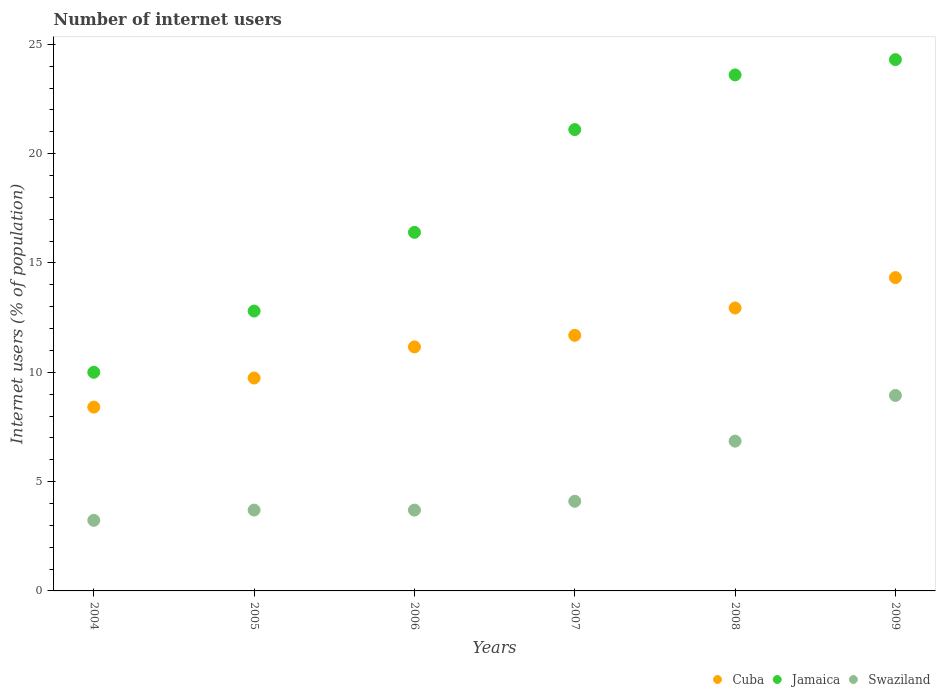What is the number of internet users in Cuba in 2009?
Offer a terse response. 14.33. Across all years, what is the maximum number of internet users in Jamaica?
Make the answer very short. 24.3. Across all years, what is the minimum number of internet users in Cuba?
Keep it short and to the point. 8.41. In which year was the number of internet users in Jamaica minimum?
Give a very brief answer. 2004. What is the total number of internet users in Jamaica in the graph?
Provide a short and direct response. 108.2. What is the difference between the number of internet users in Cuba in 2007 and that in 2008?
Your answer should be compact. -1.25. What is the difference between the number of internet users in Jamaica in 2006 and the number of internet users in Swaziland in 2008?
Ensure brevity in your answer.  9.55. What is the average number of internet users in Jamaica per year?
Your answer should be compact. 18.03. In the year 2009, what is the difference between the number of internet users in Swaziland and number of internet users in Cuba?
Ensure brevity in your answer.  -5.39. In how many years, is the number of internet users in Jamaica greater than 21 %?
Give a very brief answer. 3. What is the ratio of the number of internet users in Jamaica in 2006 to that in 2008?
Offer a terse response. 0.69. Is the number of internet users in Cuba in 2004 less than that in 2008?
Ensure brevity in your answer.  Yes. Is the difference between the number of internet users in Swaziland in 2007 and 2009 greater than the difference between the number of internet users in Cuba in 2007 and 2009?
Your answer should be very brief. No. What is the difference between the highest and the second highest number of internet users in Cuba?
Provide a succinct answer. 1.39. What is the difference between the highest and the lowest number of internet users in Swaziland?
Provide a short and direct response. 5.71. In how many years, is the number of internet users in Jamaica greater than the average number of internet users in Jamaica taken over all years?
Offer a very short reply. 3. Is the sum of the number of internet users in Swaziland in 2007 and 2009 greater than the maximum number of internet users in Jamaica across all years?
Ensure brevity in your answer.  No. Is it the case that in every year, the sum of the number of internet users in Swaziland and number of internet users in Jamaica  is greater than the number of internet users in Cuba?
Provide a succinct answer. Yes. How many years are there in the graph?
Provide a succinct answer. 6. What is the difference between two consecutive major ticks on the Y-axis?
Provide a succinct answer. 5. Are the values on the major ticks of Y-axis written in scientific E-notation?
Provide a succinct answer. No. Does the graph contain any zero values?
Keep it short and to the point. No. Does the graph contain grids?
Offer a terse response. No. How are the legend labels stacked?
Give a very brief answer. Horizontal. What is the title of the graph?
Offer a terse response. Number of internet users. What is the label or title of the Y-axis?
Offer a terse response. Internet users (% of population). What is the Internet users (% of population) in Cuba in 2004?
Your answer should be compact. 8.41. What is the Internet users (% of population) of Jamaica in 2004?
Your answer should be very brief. 10. What is the Internet users (% of population) in Swaziland in 2004?
Give a very brief answer. 3.23. What is the Internet users (% of population) of Cuba in 2005?
Provide a succinct answer. 9.74. What is the Internet users (% of population) of Swaziland in 2005?
Give a very brief answer. 3.7. What is the Internet users (% of population) of Cuba in 2006?
Provide a short and direct response. 11.16. What is the Internet users (% of population) of Swaziland in 2006?
Keep it short and to the point. 3.7. What is the Internet users (% of population) in Cuba in 2007?
Ensure brevity in your answer.  11.69. What is the Internet users (% of population) in Jamaica in 2007?
Your answer should be very brief. 21.1. What is the Internet users (% of population) in Swaziland in 2007?
Your answer should be compact. 4.1. What is the Internet users (% of population) of Cuba in 2008?
Provide a short and direct response. 12.94. What is the Internet users (% of population) in Jamaica in 2008?
Ensure brevity in your answer.  23.6. What is the Internet users (% of population) in Swaziland in 2008?
Ensure brevity in your answer.  6.85. What is the Internet users (% of population) in Cuba in 2009?
Make the answer very short. 14.33. What is the Internet users (% of population) in Jamaica in 2009?
Make the answer very short. 24.3. What is the Internet users (% of population) of Swaziland in 2009?
Provide a succinct answer. 8.94. Across all years, what is the maximum Internet users (% of population) of Cuba?
Your response must be concise. 14.33. Across all years, what is the maximum Internet users (% of population) of Jamaica?
Provide a short and direct response. 24.3. Across all years, what is the maximum Internet users (% of population) in Swaziland?
Your answer should be compact. 8.94. Across all years, what is the minimum Internet users (% of population) in Cuba?
Your answer should be very brief. 8.41. Across all years, what is the minimum Internet users (% of population) of Swaziland?
Offer a terse response. 3.23. What is the total Internet users (% of population) of Cuba in the graph?
Offer a very short reply. 68.27. What is the total Internet users (% of population) in Jamaica in the graph?
Offer a terse response. 108.2. What is the total Internet users (% of population) of Swaziland in the graph?
Your answer should be very brief. 30.51. What is the difference between the Internet users (% of population) of Cuba in 2004 and that in 2005?
Your answer should be very brief. -1.33. What is the difference between the Internet users (% of population) in Jamaica in 2004 and that in 2005?
Provide a succinct answer. -2.8. What is the difference between the Internet users (% of population) in Swaziland in 2004 and that in 2005?
Keep it short and to the point. -0.47. What is the difference between the Internet users (% of population) in Cuba in 2004 and that in 2006?
Offer a very short reply. -2.75. What is the difference between the Internet users (% of population) of Jamaica in 2004 and that in 2006?
Offer a very short reply. -6.4. What is the difference between the Internet users (% of population) of Swaziland in 2004 and that in 2006?
Your response must be concise. -0.47. What is the difference between the Internet users (% of population) in Cuba in 2004 and that in 2007?
Offer a terse response. -3.28. What is the difference between the Internet users (% of population) of Jamaica in 2004 and that in 2007?
Provide a short and direct response. -11.1. What is the difference between the Internet users (% of population) of Swaziland in 2004 and that in 2007?
Provide a succinct answer. -0.87. What is the difference between the Internet users (% of population) in Cuba in 2004 and that in 2008?
Offer a terse response. -4.53. What is the difference between the Internet users (% of population) in Jamaica in 2004 and that in 2008?
Provide a succinct answer. -13.6. What is the difference between the Internet users (% of population) in Swaziland in 2004 and that in 2008?
Offer a very short reply. -3.62. What is the difference between the Internet users (% of population) in Cuba in 2004 and that in 2009?
Offer a terse response. -5.92. What is the difference between the Internet users (% of population) in Jamaica in 2004 and that in 2009?
Keep it short and to the point. -14.3. What is the difference between the Internet users (% of population) in Swaziland in 2004 and that in 2009?
Ensure brevity in your answer.  -5.71. What is the difference between the Internet users (% of population) of Cuba in 2005 and that in 2006?
Offer a very short reply. -1.42. What is the difference between the Internet users (% of population) in Jamaica in 2005 and that in 2006?
Offer a very short reply. -3.6. What is the difference between the Internet users (% of population) in Cuba in 2005 and that in 2007?
Keep it short and to the point. -1.95. What is the difference between the Internet users (% of population) in Jamaica in 2005 and that in 2007?
Ensure brevity in your answer.  -8.3. What is the difference between the Internet users (% of population) in Swaziland in 2005 and that in 2007?
Offer a very short reply. -0.4. What is the difference between the Internet users (% of population) in Cuba in 2005 and that in 2008?
Offer a terse response. -3.2. What is the difference between the Internet users (% of population) in Jamaica in 2005 and that in 2008?
Your response must be concise. -10.8. What is the difference between the Internet users (% of population) of Swaziland in 2005 and that in 2008?
Provide a short and direct response. -3.15. What is the difference between the Internet users (% of population) of Cuba in 2005 and that in 2009?
Your answer should be very brief. -4.59. What is the difference between the Internet users (% of population) of Swaziland in 2005 and that in 2009?
Make the answer very short. -5.24. What is the difference between the Internet users (% of population) in Cuba in 2006 and that in 2007?
Provide a succinct answer. -0.53. What is the difference between the Internet users (% of population) of Jamaica in 2006 and that in 2007?
Provide a short and direct response. -4.7. What is the difference between the Internet users (% of population) of Swaziland in 2006 and that in 2007?
Provide a succinct answer. -0.4. What is the difference between the Internet users (% of population) in Cuba in 2006 and that in 2008?
Provide a succinct answer. -1.78. What is the difference between the Internet users (% of population) in Swaziland in 2006 and that in 2008?
Provide a succinct answer. -3.15. What is the difference between the Internet users (% of population) in Cuba in 2006 and that in 2009?
Your answer should be very brief. -3.17. What is the difference between the Internet users (% of population) in Jamaica in 2006 and that in 2009?
Offer a very short reply. -7.9. What is the difference between the Internet users (% of population) of Swaziland in 2006 and that in 2009?
Ensure brevity in your answer.  -5.24. What is the difference between the Internet users (% of population) of Cuba in 2007 and that in 2008?
Your answer should be very brief. -1.25. What is the difference between the Internet users (% of population) of Jamaica in 2007 and that in 2008?
Provide a succinct answer. -2.5. What is the difference between the Internet users (% of population) in Swaziland in 2007 and that in 2008?
Offer a terse response. -2.75. What is the difference between the Internet users (% of population) in Cuba in 2007 and that in 2009?
Your answer should be compact. -2.64. What is the difference between the Internet users (% of population) of Swaziland in 2007 and that in 2009?
Your answer should be very brief. -4.84. What is the difference between the Internet users (% of population) of Cuba in 2008 and that in 2009?
Give a very brief answer. -1.39. What is the difference between the Internet users (% of population) of Jamaica in 2008 and that in 2009?
Offer a very short reply. -0.7. What is the difference between the Internet users (% of population) in Swaziland in 2008 and that in 2009?
Your answer should be compact. -2.09. What is the difference between the Internet users (% of population) in Cuba in 2004 and the Internet users (% of population) in Jamaica in 2005?
Your answer should be very brief. -4.39. What is the difference between the Internet users (% of population) of Cuba in 2004 and the Internet users (% of population) of Swaziland in 2005?
Offer a terse response. 4.71. What is the difference between the Internet users (% of population) in Jamaica in 2004 and the Internet users (% of population) in Swaziland in 2005?
Ensure brevity in your answer.  6.3. What is the difference between the Internet users (% of population) in Cuba in 2004 and the Internet users (% of population) in Jamaica in 2006?
Give a very brief answer. -7.99. What is the difference between the Internet users (% of population) in Cuba in 2004 and the Internet users (% of population) in Swaziland in 2006?
Keep it short and to the point. 4.71. What is the difference between the Internet users (% of population) of Jamaica in 2004 and the Internet users (% of population) of Swaziland in 2006?
Offer a terse response. 6.3. What is the difference between the Internet users (% of population) in Cuba in 2004 and the Internet users (% of population) in Jamaica in 2007?
Your response must be concise. -12.69. What is the difference between the Internet users (% of population) of Cuba in 2004 and the Internet users (% of population) of Swaziland in 2007?
Make the answer very short. 4.31. What is the difference between the Internet users (% of population) of Cuba in 2004 and the Internet users (% of population) of Jamaica in 2008?
Make the answer very short. -15.19. What is the difference between the Internet users (% of population) in Cuba in 2004 and the Internet users (% of population) in Swaziland in 2008?
Provide a short and direct response. 1.56. What is the difference between the Internet users (% of population) of Jamaica in 2004 and the Internet users (% of population) of Swaziland in 2008?
Your answer should be compact. 3.15. What is the difference between the Internet users (% of population) in Cuba in 2004 and the Internet users (% of population) in Jamaica in 2009?
Keep it short and to the point. -15.89. What is the difference between the Internet users (% of population) of Cuba in 2004 and the Internet users (% of population) of Swaziland in 2009?
Your answer should be very brief. -0.53. What is the difference between the Internet users (% of population) of Jamaica in 2004 and the Internet users (% of population) of Swaziland in 2009?
Your answer should be compact. 1.06. What is the difference between the Internet users (% of population) in Cuba in 2005 and the Internet users (% of population) in Jamaica in 2006?
Provide a succinct answer. -6.66. What is the difference between the Internet users (% of population) of Cuba in 2005 and the Internet users (% of population) of Swaziland in 2006?
Your answer should be very brief. 6.04. What is the difference between the Internet users (% of population) in Jamaica in 2005 and the Internet users (% of population) in Swaziland in 2006?
Provide a short and direct response. 9.1. What is the difference between the Internet users (% of population) of Cuba in 2005 and the Internet users (% of population) of Jamaica in 2007?
Make the answer very short. -11.36. What is the difference between the Internet users (% of population) of Cuba in 2005 and the Internet users (% of population) of Swaziland in 2007?
Provide a succinct answer. 5.64. What is the difference between the Internet users (% of population) of Cuba in 2005 and the Internet users (% of population) of Jamaica in 2008?
Keep it short and to the point. -13.86. What is the difference between the Internet users (% of population) of Cuba in 2005 and the Internet users (% of population) of Swaziland in 2008?
Your response must be concise. 2.89. What is the difference between the Internet users (% of population) of Jamaica in 2005 and the Internet users (% of population) of Swaziland in 2008?
Ensure brevity in your answer.  5.95. What is the difference between the Internet users (% of population) of Cuba in 2005 and the Internet users (% of population) of Jamaica in 2009?
Give a very brief answer. -14.56. What is the difference between the Internet users (% of population) in Cuba in 2005 and the Internet users (% of population) in Swaziland in 2009?
Offer a very short reply. 0.8. What is the difference between the Internet users (% of population) of Jamaica in 2005 and the Internet users (% of population) of Swaziland in 2009?
Ensure brevity in your answer.  3.86. What is the difference between the Internet users (% of population) of Cuba in 2006 and the Internet users (% of population) of Jamaica in 2007?
Ensure brevity in your answer.  -9.94. What is the difference between the Internet users (% of population) in Cuba in 2006 and the Internet users (% of population) in Swaziland in 2007?
Offer a very short reply. 7.06. What is the difference between the Internet users (% of population) of Jamaica in 2006 and the Internet users (% of population) of Swaziland in 2007?
Ensure brevity in your answer.  12.3. What is the difference between the Internet users (% of population) of Cuba in 2006 and the Internet users (% of population) of Jamaica in 2008?
Ensure brevity in your answer.  -12.44. What is the difference between the Internet users (% of population) of Cuba in 2006 and the Internet users (% of population) of Swaziland in 2008?
Provide a succinct answer. 4.31. What is the difference between the Internet users (% of population) of Jamaica in 2006 and the Internet users (% of population) of Swaziland in 2008?
Ensure brevity in your answer.  9.55. What is the difference between the Internet users (% of population) in Cuba in 2006 and the Internet users (% of population) in Jamaica in 2009?
Ensure brevity in your answer.  -13.14. What is the difference between the Internet users (% of population) in Cuba in 2006 and the Internet users (% of population) in Swaziland in 2009?
Offer a terse response. 2.22. What is the difference between the Internet users (% of population) of Jamaica in 2006 and the Internet users (% of population) of Swaziland in 2009?
Ensure brevity in your answer.  7.46. What is the difference between the Internet users (% of population) in Cuba in 2007 and the Internet users (% of population) in Jamaica in 2008?
Ensure brevity in your answer.  -11.91. What is the difference between the Internet users (% of population) in Cuba in 2007 and the Internet users (% of population) in Swaziland in 2008?
Offer a terse response. 4.84. What is the difference between the Internet users (% of population) of Jamaica in 2007 and the Internet users (% of population) of Swaziland in 2008?
Ensure brevity in your answer.  14.25. What is the difference between the Internet users (% of population) in Cuba in 2007 and the Internet users (% of population) in Jamaica in 2009?
Your answer should be compact. -12.61. What is the difference between the Internet users (% of population) in Cuba in 2007 and the Internet users (% of population) in Swaziland in 2009?
Your response must be concise. 2.75. What is the difference between the Internet users (% of population) of Jamaica in 2007 and the Internet users (% of population) of Swaziland in 2009?
Make the answer very short. 12.16. What is the difference between the Internet users (% of population) of Cuba in 2008 and the Internet users (% of population) of Jamaica in 2009?
Provide a short and direct response. -11.36. What is the difference between the Internet users (% of population) in Cuba in 2008 and the Internet users (% of population) in Swaziland in 2009?
Give a very brief answer. 4. What is the difference between the Internet users (% of population) of Jamaica in 2008 and the Internet users (% of population) of Swaziland in 2009?
Ensure brevity in your answer.  14.66. What is the average Internet users (% of population) of Cuba per year?
Provide a succinct answer. 11.38. What is the average Internet users (% of population) in Jamaica per year?
Keep it short and to the point. 18.03. What is the average Internet users (% of population) of Swaziland per year?
Provide a short and direct response. 5.09. In the year 2004, what is the difference between the Internet users (% of population) in Cuba and Internet users (% of population) in Jamaica?
Your answer should be compact. -1.59. In the year 2004, what is the difference between the Internet users (% of population) in Cuba and Internet users (% of population) in Swaziland?
Keep it short and to the point. 5.18. In the year 2004, what is the difference between the Internet users (% of population) in Jamaica and Internet users (% of population) in Swaziland?
Your response must be concise. 6.77. In the year 2005, what is the difference between the Internet users (% of population) in Cuba and Internet users (% of population) in Jamaica?
Ensure brevity in your answer.  -3.06. In the year 2005, what is the difference between the Internet users (% of population) of Cuba and Internet users (% of population) of Swaziland?
Your response must be concise. 6.04. In the year 2005, what is the difference between the Internet users (% of population) in Jamaica and Internet users (% of population) in Swaziland?
Your response must be concise. 9.1. In the year 2006, what is the difference between the Internet users (% of population) of Cuba and Internet users (% of population) of Jamaica?
Your response must be concise. -5.24. In the year 2006, what is the difference between the Internet users (% of population) in Cuba and Internet users (% of population) in Swaziland?
Offer a terse response. 7.46. In the year 2006, what is the difference between the Internet users (% of population) of Jamaica and Internet users (% of population) of Swaziland?
Your response must be concise. 12.7. In the year 2007, what is the difference between the Internet users (% of population) of Cuba and Internet users (% of population) of Jamaica?
Your response must be concise. -9.41. In the year 2007, what is the difference between the Internet users (% of population) of Cuba and Internet users (% of population) of Swaziland?
Give a very brief answer. 7.59. In the year 2008, what is the difference between the Internet users (% of population) of Cuba and Internet users (% of population) of Jamaica?
Give a very brief answer. -10.66. In the year 2008, what is the difference between the Internet users (% of population) of Cuba and Internet users (% of population) of Swaziland?
Ensure brevity in your answer.  6.09. In the year 2008, what is the difference between the Internet users (% of population) of Jamaica and Internet users (% of population) of Swaziland?
Your answer should be very brief. 16.75. In the year 2009, what is the difference between the Internet users (% of population) of Cuba and Internet users (% of population) of Jamaica?
Your response must be concise. -9.97. In the year 2009, what is the difference between the Internet users (% of population) of Cuba and Internet users (% of population) of Swaziland?
Make the answer very short. 5.39. In the year 2009, what is the difference between the Internet users (% of population) in Jamaica and Internet users (% of population) in Swaziland?
Give a very brief answer. 15.36. What is the ratio of the Internet users (% of population) of Cuba in 2004 to that in 2005?
Make the answer very short. 0.86. What is the ratio of the Internet users (% of population) in Jamaica in 2004 to that in 2005?
Keep it short and to the point. 0.78. What is the ratio of the Internet users (% of population) in Swaziland in 2004 to that in 2005?
Provide a succinct answer. 0.87. What is the ratio of the Internet users (% of population) in Cuba in 2004 to that in 2006?
Ensure brevity in your answer.  0.75. What is the ratio of the Internet users (% of population) of Jamaica in 2004 to that in 2006?
Give a very brief answer. 0.61. What is the ratio of the Internet users (% of population) in Swaziland in 2004 to that in 2006?
Your answer should be compact. 0.87. What is the ratio of the Internet users (% of population) in Cuba in 2004 to that in 2007?
Your response must be concise. 0.72. What is the ratio of the Internet users (% of population) in Jamaica in 2004 to that in 2007?
Keep it short and to the point. 0.47. What is the ratio of the Internet users (% of population) in Swaziland in 2004 to that in 2007?
Give a very brief answer. 0.79. What is the ratio of the Internet users (% of population) in Cuba in 2004 to that in 2008?
Ensure brevity in your answer.  0.65. What is the ratio of the Internet users (% of population) in Jamaica in 2004 to that in 2008?
Provide a short and direct response. 0.42. What is the ratio of the Internet users (% of population) in Swaziland in 2004 to that in 2008?
Give a very brief answer. 0.47. What is the ratio of the Internet users (% of population) of Cuba in 2004 to that in 2009?
Your response must be concise. 0.59. What is the ratio of the Internet users (% of population) of Jamaica in 2004 to that in 2009?
Offer a terse response. 0.41. What is the ratio of the Internet users (% of population) in Swaziland in 2004 to that in 2009?
Your response must be concise. 0.36. What is the ratio of the Internet users (% of population) of Cuba in 2005 to that in 2006?
Make the answer very short. 0.87. What is the ratio of the Internet users (% of population) of Jamaica in 2005 to that in 2006?
Provide a succinct answer. 0.78. What is the ratio of the Internet users (% of population) of Swaziland in 2005 to that in 2006?
Offer a terse response. 1. What is the ratio of the Internet users (% of population) of Cuba in 2005 to that in 2007?
Make the answer very short. 0.83. What is the ratio of the Internet users (% of population) in Jamaica in 2005 to that in 2007?
Your answer should be very brief. 0.61. What is the ratio of the Internet users (% of population) of Swaziland in 2005 to that in 2007?
Your answer should be very brief. 0.9. What is the ratio of the Internet users (% of population) of Cuba in 2005 to that in 2008?
Your response must be concise. 0.75. What is the ratio of the Internet users (% of population) in Jamaica in 2005 to that in 2008?
Make the answer very short. 0.54. What is the ratio of the Internet users (% of population) in Swaziland in 2005 to that in 2008?
Offer a very short reply. 0.54. What is the ratio of the Internet users (% of population) in Cuba in 2005 to that in 2009?
Keep it short and to the point. 0.68. What is the ratio of the Internet users (% of population) of Jamaica in 2005 to that in 2009?
Make the answer very short. 0.53. What is the ratio of the Internet users (% of population) in Swaziland in 2005 to that in 2009?
Offer a very short reply. 0.41. What is the ratio of the Internet users (% of population) in Cuba in 2006 to that in 2007?
Provide a short and direct response. 0.95. What is the ratio of the Internet users (% of population) in Jamaica in 2006 to that in 2007?
Offer a terse response. 0.78. What is the ratio of the Internet users (% of population) of Swaziland in 2006 to that in 2007?
Ensure brevity in your answer.  0.9. What is the ratio of the Internet users (% of population) in Cuba in 2006 to that in 2008?
Offer a very short reply. 0.86. What is the ratio of the Internet users (% of population) of Jamaica in 2006 to that in 2008?
Provide a short and direct response. 0.69. What is the ratio of the Internet users (% of population) in Swaziland in 2006 to that in 2008?
Your response must be concise. 0.54. What is the ratio of the Internet users (% of population) in Cuba in 2006 to that in 2009?
Your answer should be compact. 0.78. What is the ratio of the Internet users (% of population) of Jamaica in 2006 to that in 2009?
Keep it short and to the point. 0.67. What is the ratio of the Internet users (% of population) in Swaziland in 2006 to that in 2009?
Ensure brevity in your answer.  0.41. What is the ratio of the Internet users (% of population) of Cuba in 2007 to that in 2008?
Your answer should be very brief. 0.9. What is the ratio of the Internet users (% of population) in Jamaica in 2007 to that in 2008?
Keep it short and to the point. 0.89. What is the ratio of the Internet users (% of population) in Swaziland in 2007 to that in 2008?
Your response must be concise. 0.6. What is the ratio of the Internet users (% of population) in Cuba in 2007 to that in 2009?
Offer a very short reply. 0.82. What is the ratio of the Internet users (% of population) in Jamaica in 2007 to that in 2009?
Ensure brevity in your answer.  0.87. What is the ratio of the Internet users (% of population) of Swaziland in 2007 to that in 2009?
Provide a succinct answer. 0.46. What is the ratio of the Internet users (% of population) of Cuba in 2008 to that in 2009?
Make the answer very short. 0.9. What is the ratio of the Internet users (% of population) of Jamaica in 2008 to that in 2009?
Your response must be concise. 0.97. What is the ratio of the Internet users (% of population) of Swaziland in 2008 to that in 2009?
Offer a terse response. 0.77. What is the difference between the highest and the second highest Internet users (% of population) in Cuba?
Keep it short and to the point. 1.39. What is the difference between the highest and the second highest Internet users (% of population) in Swaziland?
Your answer should be compact. 2.09. What is the difference between the highest and the lowest Internet users (% of population) of Cuba?
Provide a short and direct response. 5.92. What is the difference between the highest and the lowest Internet users (% of population) of Swaziland?
Your answer should be compact. 5.71. 